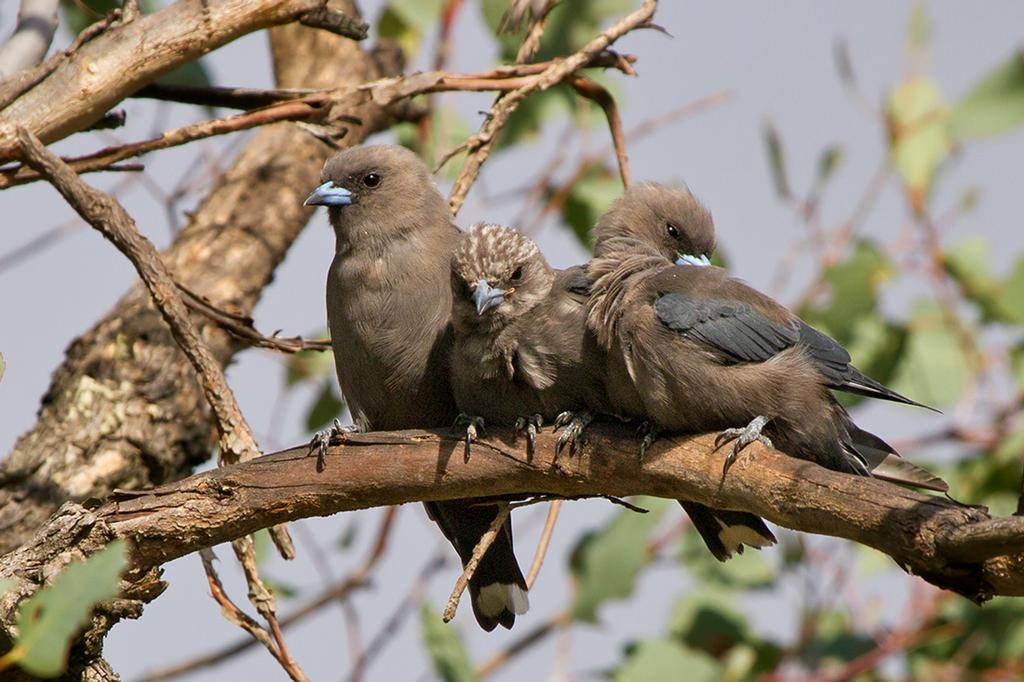How many birds are in the image? There are three birds in the image. Where are the birds located? The birds are on the branch of a tree. What can be seen in the background of the image? There is sky visible in the background of the image. What type of punishment is being given to the dogs in the image? There are no dogs present in the image, so there is no punishment being given. 